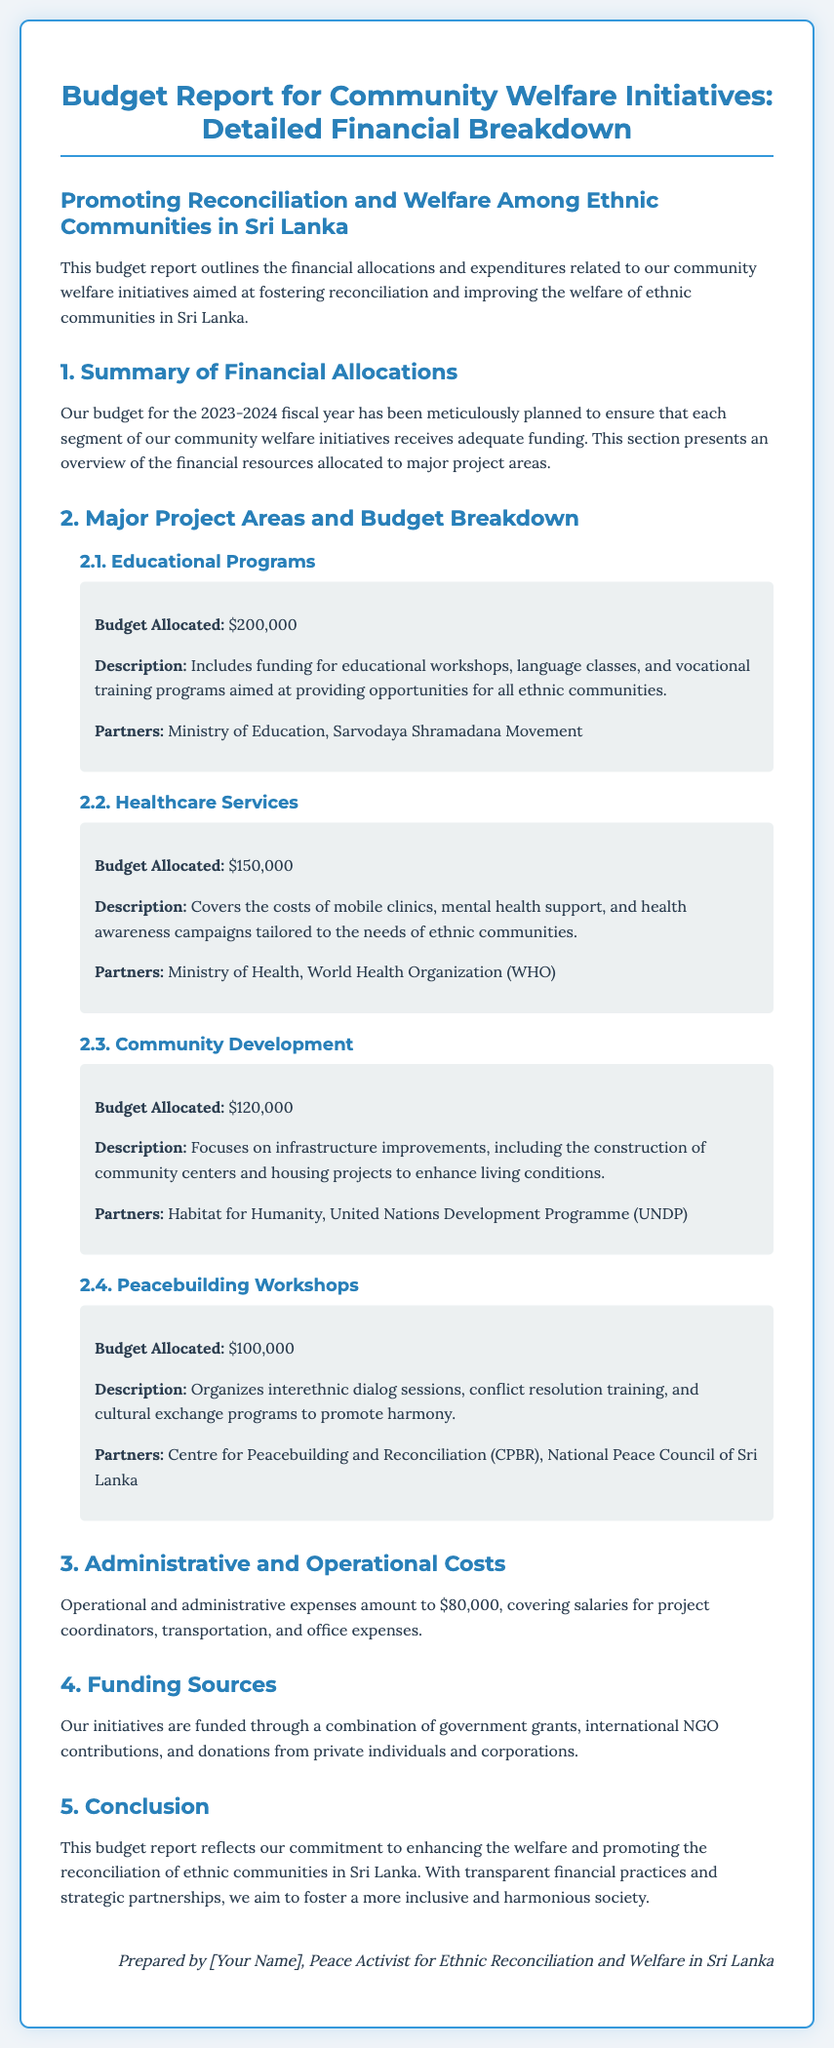what is the total budget allocated for Educational Programs? The total budget allocated is stated in the document as $200,000.
Answer: $200,000 who are the partners associated with Healthcare Services? The partners listed in the document for Healthcare Services are the Ministry of Health and the World Health Organization (WHO).
Answer: Ministry of Health, World Health Organization what percentage of the overall budget is allocated to Community Development? The allocations for Educational Programs, Healthcare Services, Community Development, and Peacebuilding Workshops should be totaled and then Community Development's budget of $120,000 computed as a percentage of this total. The total would be $670,000, making the percentage approximately 17.91%.
Answer: 17.91% how much is allocated for Peacebuilding Workshops? The budget allocated for Peacebuilding Workshops is specified as $100,000 in the document.
Answer: $100,000 what is the purpose of the funding from private individuals and corporations? Private individuals and corporations provide funding to support the community welfare initiatives as indicated in the Funding Sources section.
Answer: Community welfare initiatives what are the operational costs listed in the document? The administrative and operational costs amount to $80,000, as mentioned in the report.
Answer: $80,000 which project focuses on infrastructure improvements? The project focusing on infrastructure improvements is identified as Community Development in the Major Project Areas section.
Answer: Community Development what is the goal of the Peacebuilding Workshops? The goal of the Peacebuilding Workshops is to promote harmony through interethnic dialog sessions and cultural exchange programs.
Answer: Promote harmony 